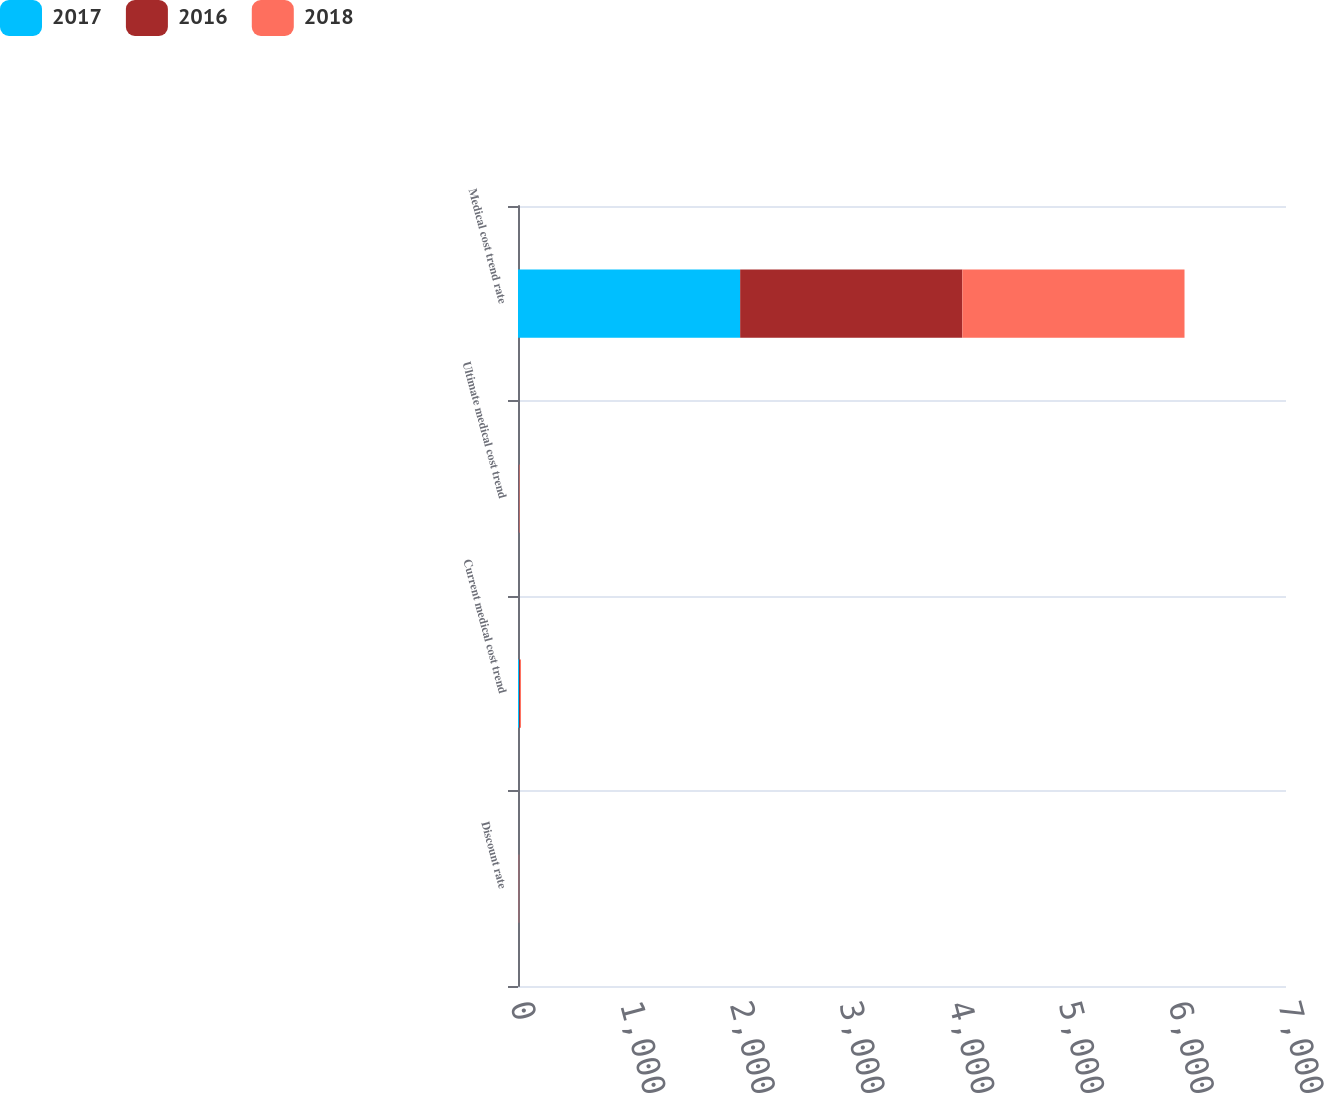Convert chart to OTSL. <chart><loc_0><loc_0><loc_500><loc_500><stacked_bar_chart><ecel><fcel>Discount rate<fcel>Current medical cost trend<fcel>Ultimate medical cost trend<fcel>Medical cost trend rate<nl><fcel>2017<fcel>3.46<fcel>9.79<fcel>4.5<fcel>2025<nl><fcel>2016<fcel>3.15<fcel>8.68<fcel>4.5<fcel>2025<nl><fcel>2018<fcel>3.96<fcel>9<fcel>4.5<fcel>2025<nl></chart> 